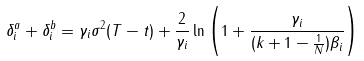Convert formula to latex. <formula><loc_0><loc_0><loc_500><loc_500>\delta _ { i } ^ { a } + \delta _ { i } ^ { b } = \gamma _ { i } \sigma ^ { 2 } ( T - t ) + \frac { 2 } { \gamma _ { i } } \ln \left ( 1 + \frac { \gamma _ { i } } { ( k + 1 - \frac { 1 } { N } ) \beta _ { i } } \right )</formula> 